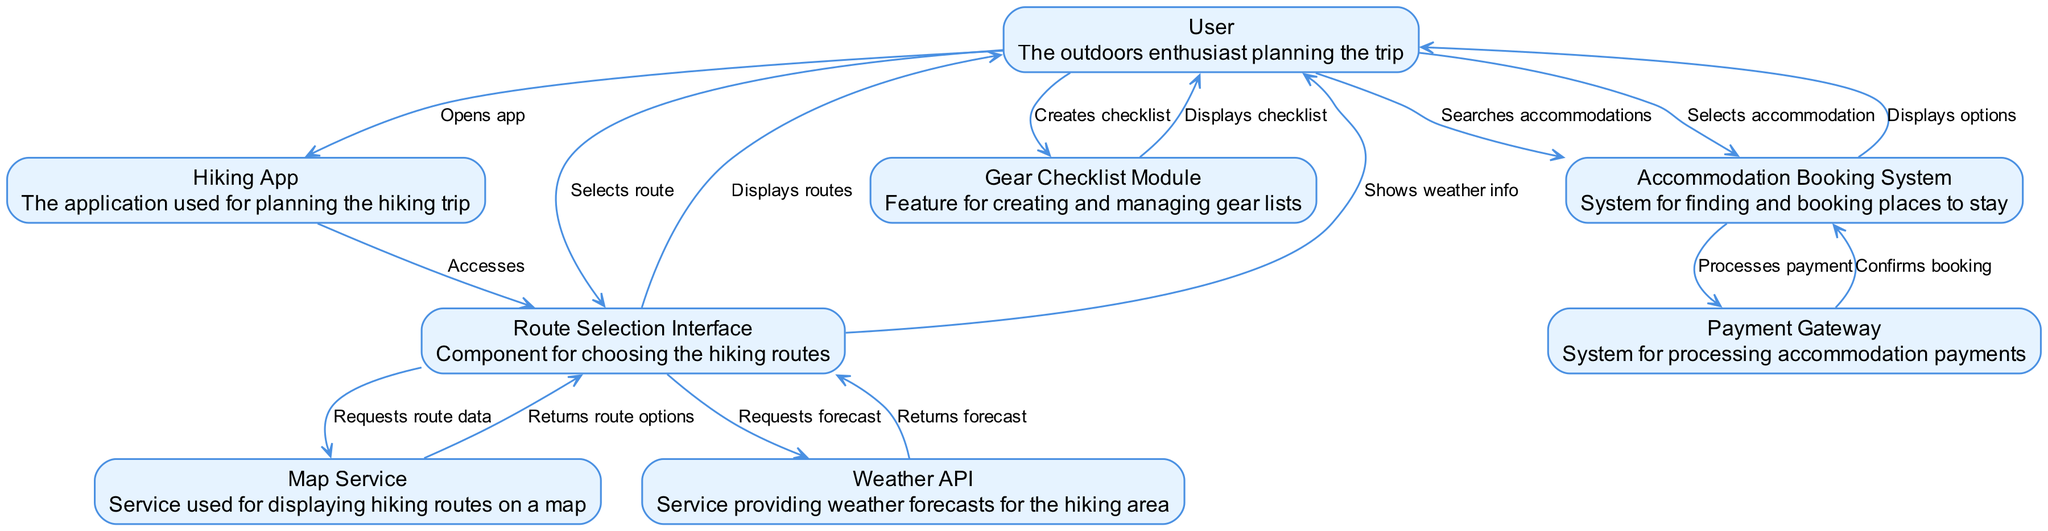What is the first action taken by the User? The User opens the hiking app, which is the starting point of the interaction. This is indicated by the initial edge from the User to the Hiking App labeled 'Opens app'.
Answer: Opens app How many nodes are present in the diagram? The diagram includes 7 distinct elements representing various components like User, Hiking App, Route Selection Interface, and others, leading to a total of 7 nodes.
Answer: 7 What does the User do after selecting a route? After the User selects a route, the next action is to request the weather forecast via the Route Selection Interface to gain more information about the selected route.
Answer: Requests forecast Which component confirms the booking after payment processing? The Accommodation Booking System receives confirmation from the Payment Gateway once the payment processes successfully, as shown by the edge labeled 'Confirms booking'.
Answer: Accommodation Booking System Which service provides the weather forecasts? The Weather API is specified as the service that supplies the weather forecasts, which is evident from its mention in the edges leading to and from the Route Selection Interface.
Answer: Weather API What is displayed to the User after they create a gear checklist? Once the User creates a checklist, the Gear Checklist Module displays that checklist back to the User, as indicated by the edge labeled 'Displays checklist'.
Answer: Displays checklist What action requires the User to interact with the Accommodation Booking System directly? The User interacts directly with the Accommodation Booking System by searching for accommodations, which is defined in the diagram by the edge labeled 'Searches accommodations'.
Answer: Searches accommodations Which two components are part of the accommodation booking process? The two components involved in the accommodation booking process are the Accommodation Booking System and the Payment Gateway, as these elements are shown linked in the sequence of actions regarding booking accommodations.
Answer: Accommodation Booking System and Payment Gateway 